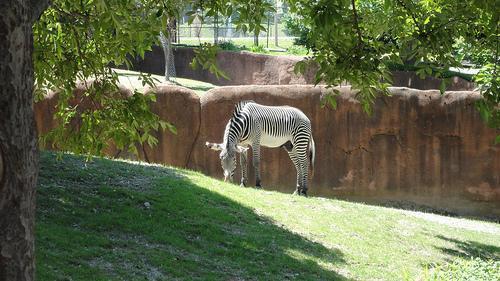How many zebras are there?
Give a very brief answer. 1. 